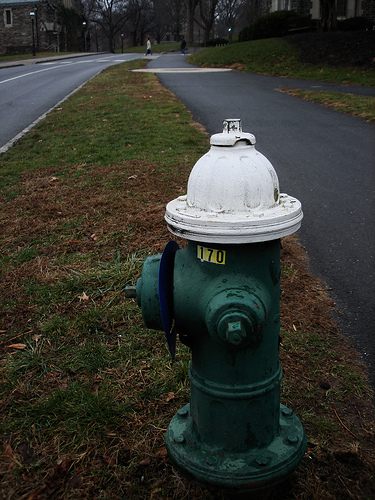Please provide the bounding box coordinate of the region this sentence describes: Green bolt on fire hydrant. The provided coordinates for the green bolt on the fire hydrant, [0.69, 0.86, 0.72, 0.89], pinpoint a crucial component, likely used to operate the valve mechanism inside. 